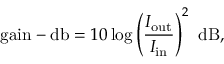<formula> <loc_0><loc_0><loc_500><loc_500>{ g a i n - d b } = 1 0 \log \left ( { \frac { I _ { o u t } } { I _ { i n } } } \right ) ^ { 2 } { d B } ,</formula> 